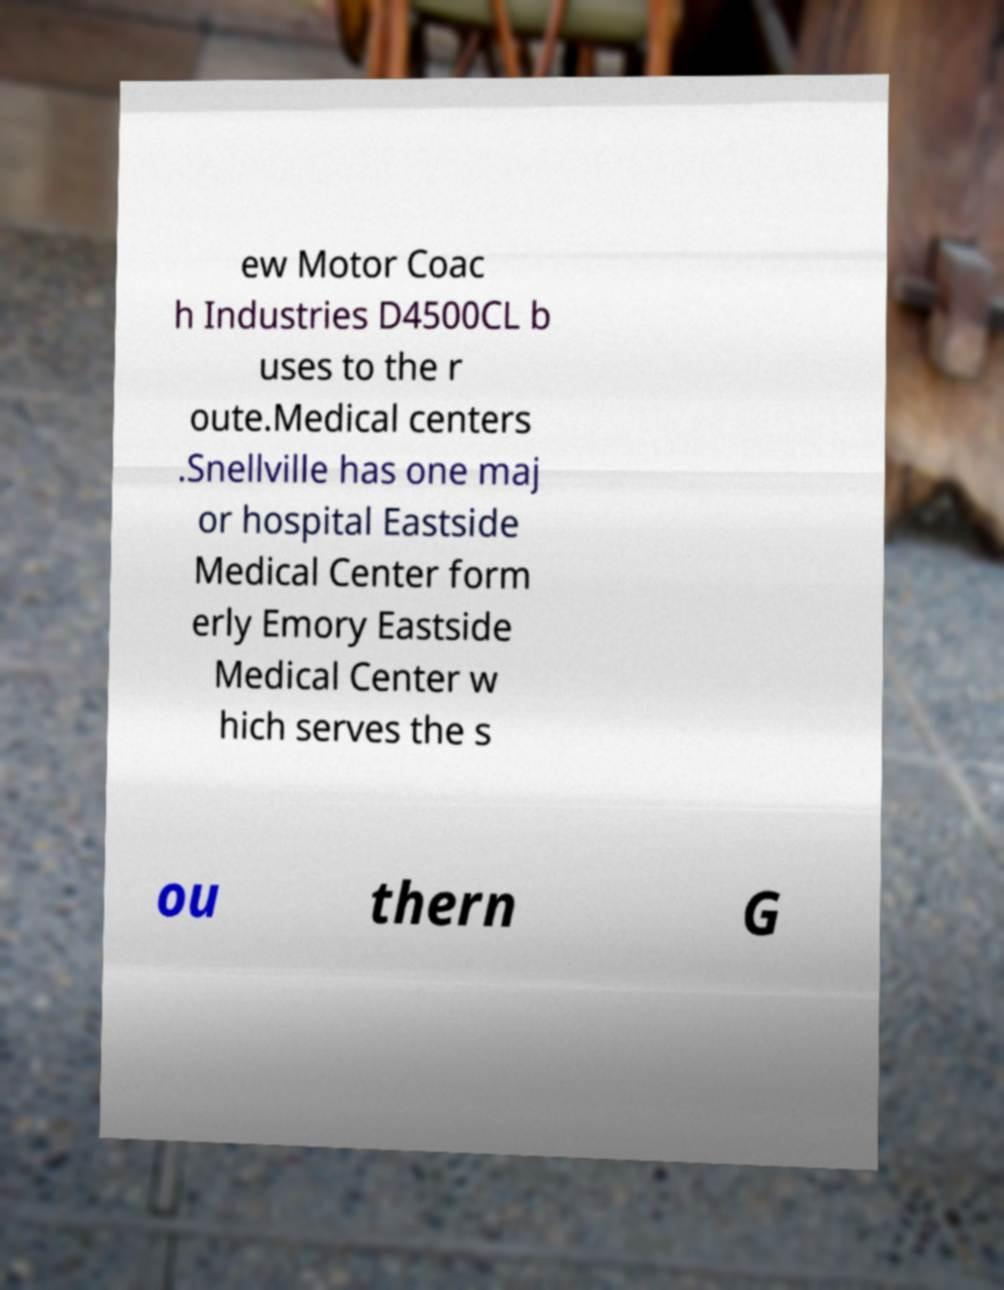Can you read and provide the text displayed in the image?This photo seems to have some interesting text. Can you extract and type it out for me? ew Motor Coac h Industries D4500CL b uses to the r oute.Medical centers .Snellville has one maj or hospital Eastside Medical Center form erly Emory Eastside Medical Center w hich serves the s ou thern G 